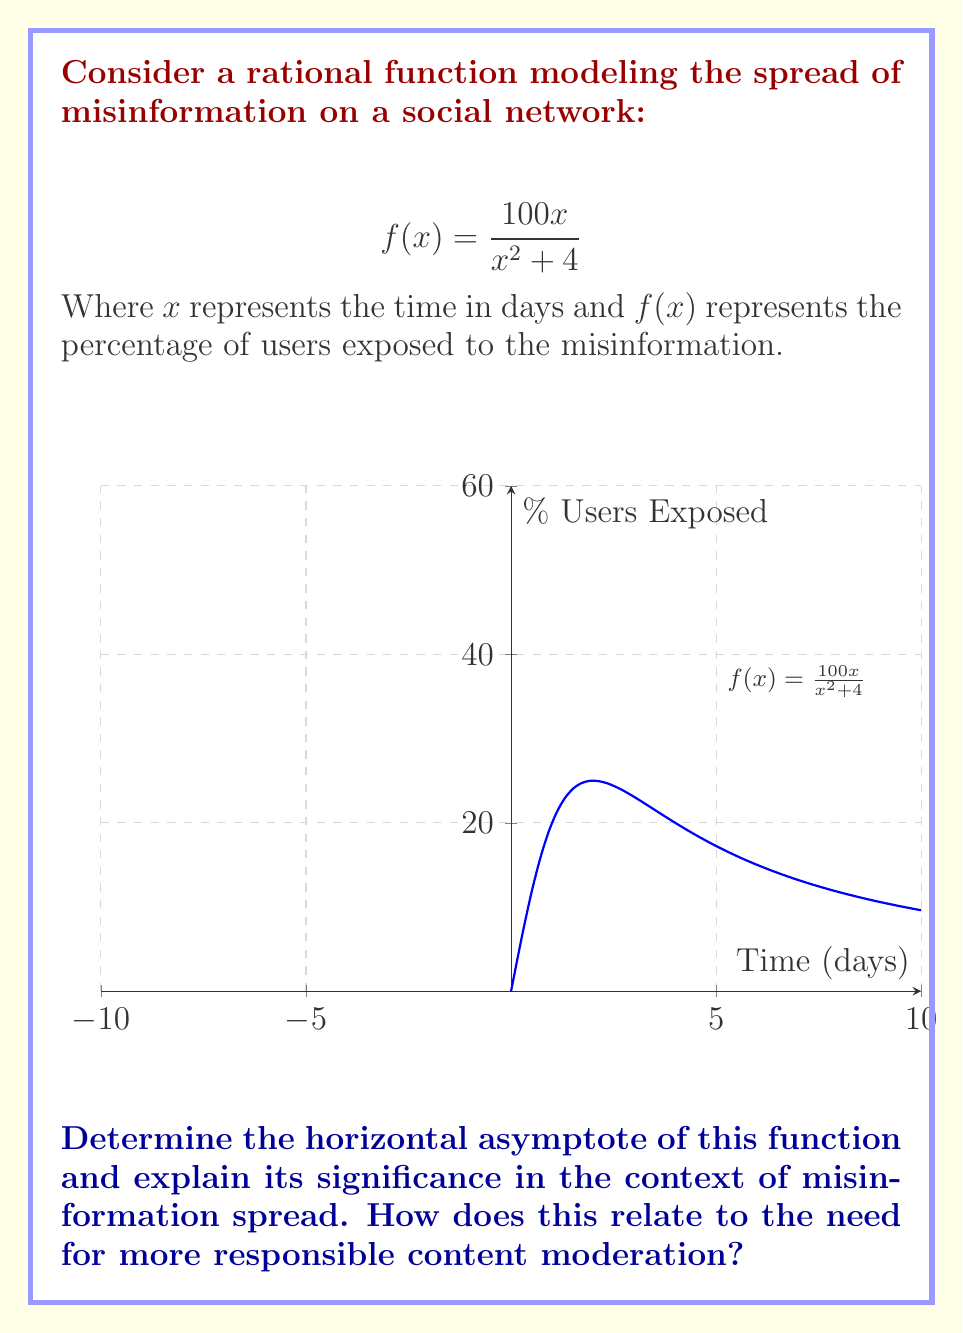What is the answer to this math problem? To find the horizontal asymptote, we need to examine the behavior of the function as $x$ approaches infinity:

1) For rational functions of the form $\frac{P(x)}{Q(x)}$, where $P(x)$ and $Q(x)$ are polynomials, the horizontal asymptote is determined by comparing the degrees of $P(x)$ and $Q(x)$.

2) In this case, $P(x) = 100x$ (degree 1) and $Q(x) = x^2 + 4$ (degree 2).

3) When the degree of $Q(x)$ is greater than the degree of $P(x)$, the horizontal asymptote is $y = 0$.

4) We can verify this algebraically:

   $$\lim_{x \to \infty} f(x) = \lim_{x \to \infty} \frac{100x}{x^2 + 4} = \lim_{x \to \infty} \frac{100}{x + \frac{4}{x}} = 0$$

5) Significance: The horizontal asymptote at $y = 0$ indicates that as time progresses indefinitely, the rate of misinformation spread approaches zero. However, this doesn't mean the misinformation disappears; it suggests that the spread slows down but potentially reaches a large portion of the network.

6) Relation to content moderation: This model demonstrates that without intervention, misinformation can spread rapidly initially before slowing down. Responsible content moderation could help lower the peak of the curve and accelerate the approach to the asymptote, limiting the overall spread of misinformation.
Answer: $y = 0$ 